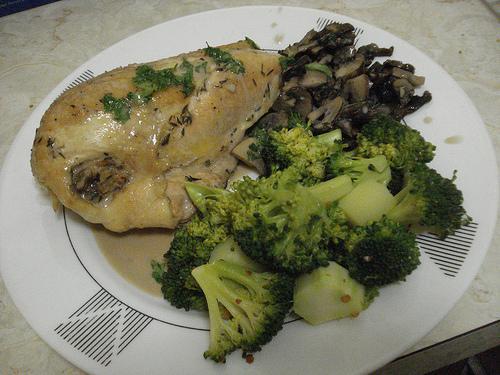How many dinners are in the picture?
Give a very brief answer. 1. How many pieces of chicken are on the plate?
Give a very brief answer. 1. 